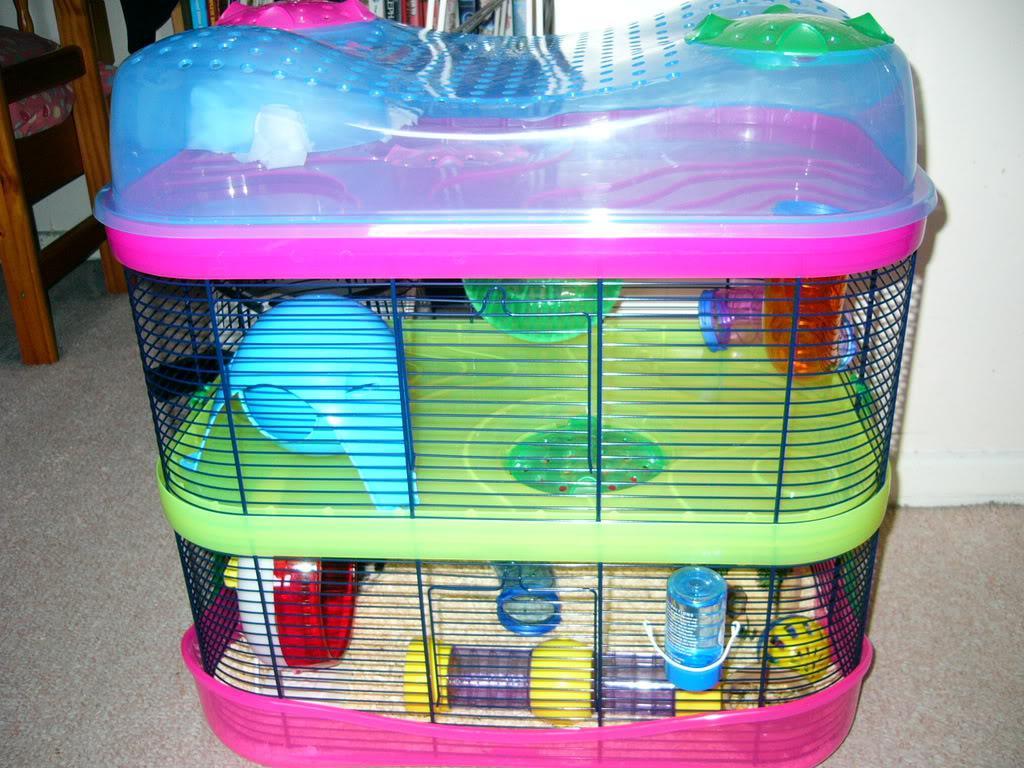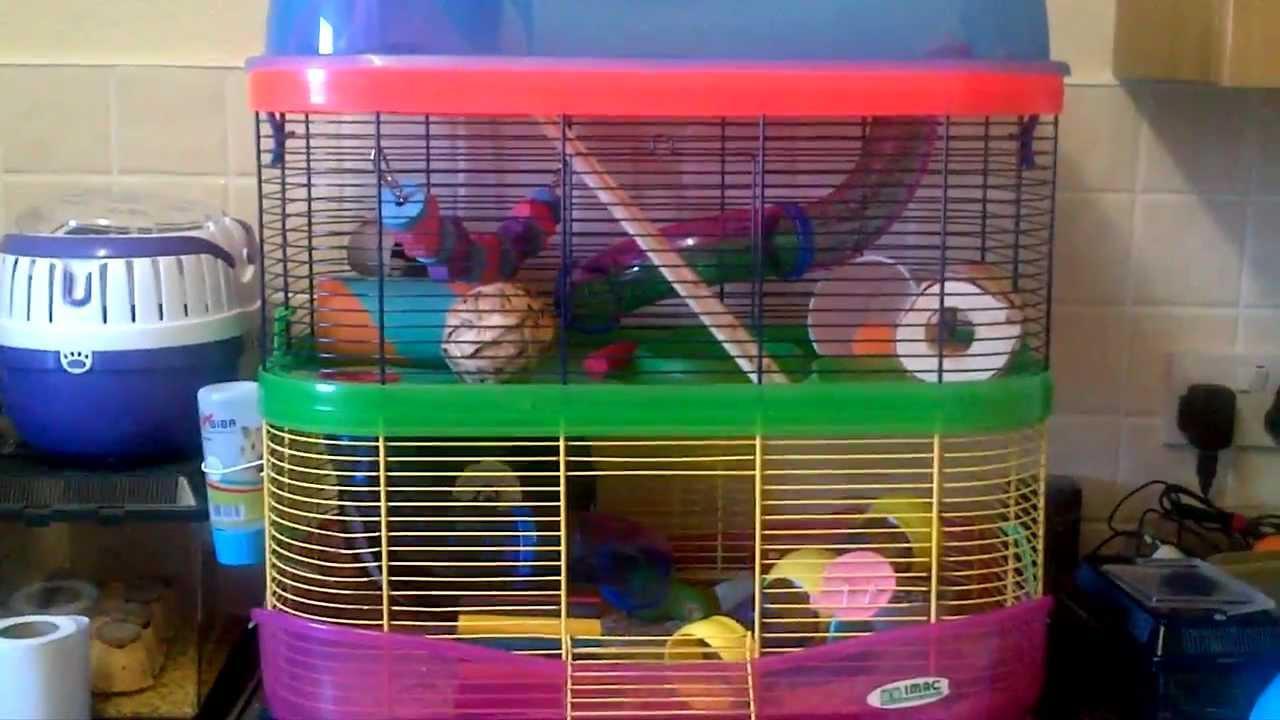The first image is the image on the left, the second image is the image on the right. For the images shown, is this caption "A small pet habitat features a white disk with purple border and yellow dot at the center." true? Answer yes or no. No. The first image is the image on the left, the second image is the image on the right. Analyze the images presented: Is the assertion "Both hamster cages have 2 stories." valid? Answer yes or no. Yes. 